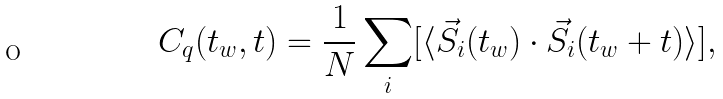<formula> <loc_0><loc_0><loc_500><loc_500>C _ { q } ( t _ { w } , t ) = \frac { 1 } { N } \sum _ { i } [ \langle \vec { S } _ { i } ( t _ { w } ) \cdot \vec { S } _ { i } ( t _ { w } + t ) \rangle ] ,</formula> 